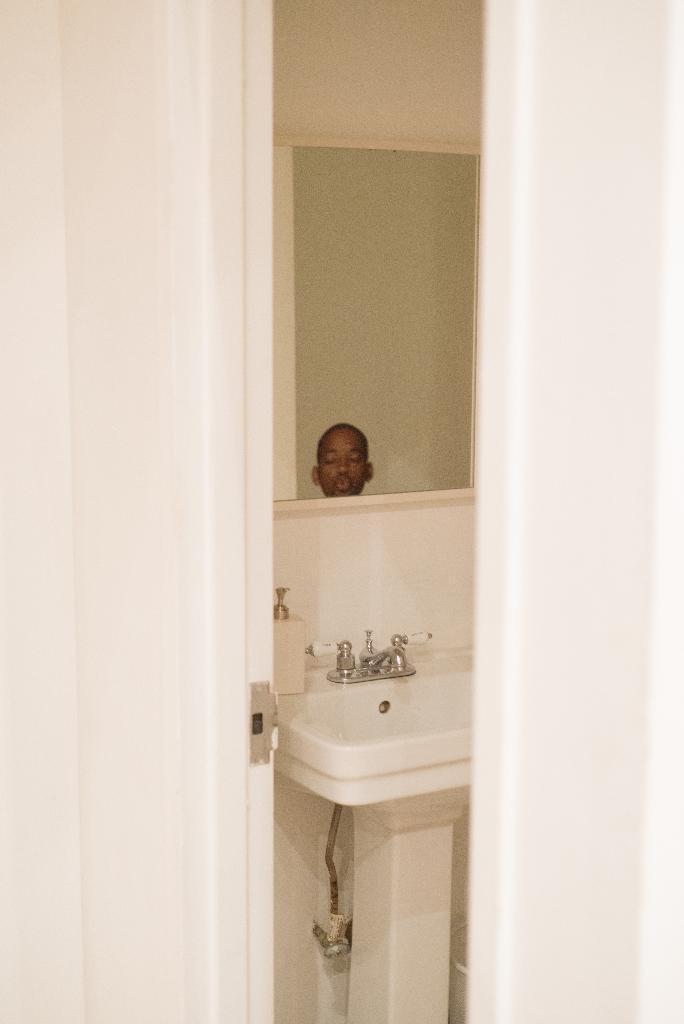In one or two sentences, can you explain what this image depicts? On the right side of the image we can see a white color wall. In the middle we can see a mirror, in that mirror we can see a person face and wash basin with two taps. On the left side we have white color wall. 